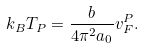<formula> <loc_0><loc_0><loc_500><loc_500>k _ { B } T _ { P } = \frac { b } { 4 \pi ^ { 2 } a _ { 0 } } v _ { F } ^ { P } .</formula> 